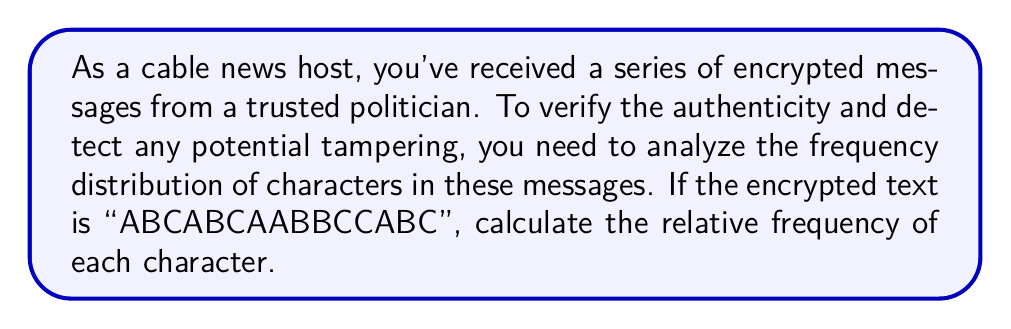Provide a solution to this math problem. To calculate the relative frequency distribution of characters in the encrypted message, we'll follow these steps:

1. Count the total number of characters:
   Total characters = 15

2. Count the occurrences of each character:
   A: 5 occurrences
   B: 5 occurrences
   C: 5 occurrences

3. Calculate the relative frequency for each character:
   Relative frequency = Number of occurrences / Total characters

   For A: $f_A = \frac{5}{15} = \frac{1}{3} \approx 0.3333$
   For B: $f_B = \frac{5}{15} = \frac{1}{3} \approx 0.3333$
   For C: $f_C = \frac{5}{15} = \frac{1}{3} \approx 0.3333$

4. Verify that the sum of all relative frequencies equals 1:
   $f_A + f_B + f_C = \frac{1}{3} + \frac{1}{3} + \frac{1}{3} = 1$

The relative frequency distribution shows that each character (A, B, and C) appears with equal frequency in the encrypted message.
Answer: A: $\frac{1}{3}$, B: $\frac{1}{3}$, C: $\frac{1}{3}$ 